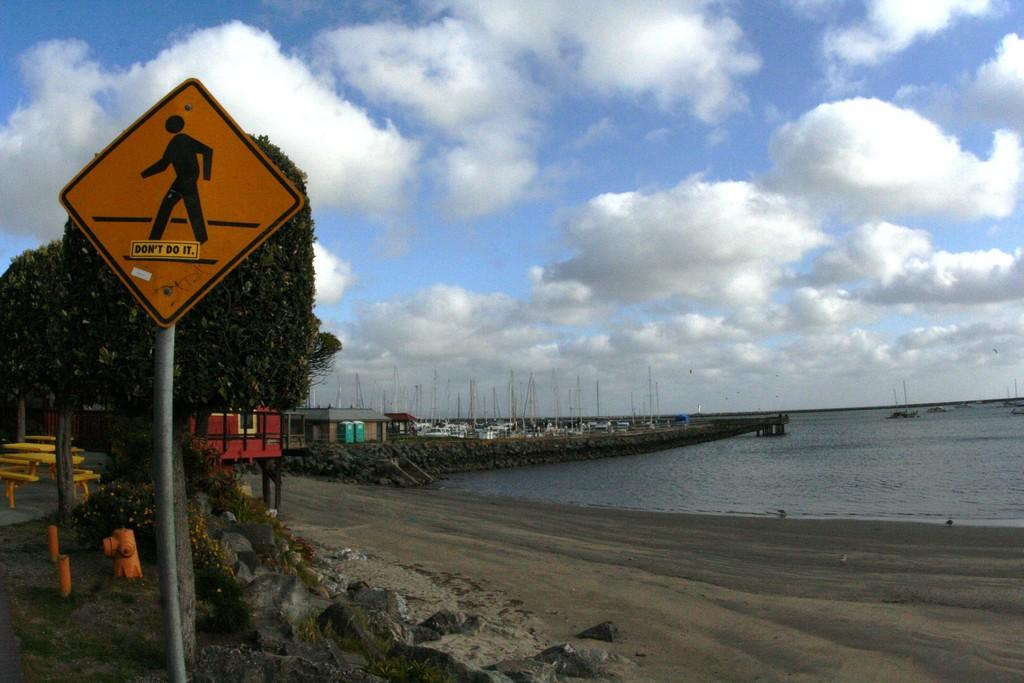Provide a one-sentence caption for the provided image. A sticker on the pedestrian sign says "don't do it". 